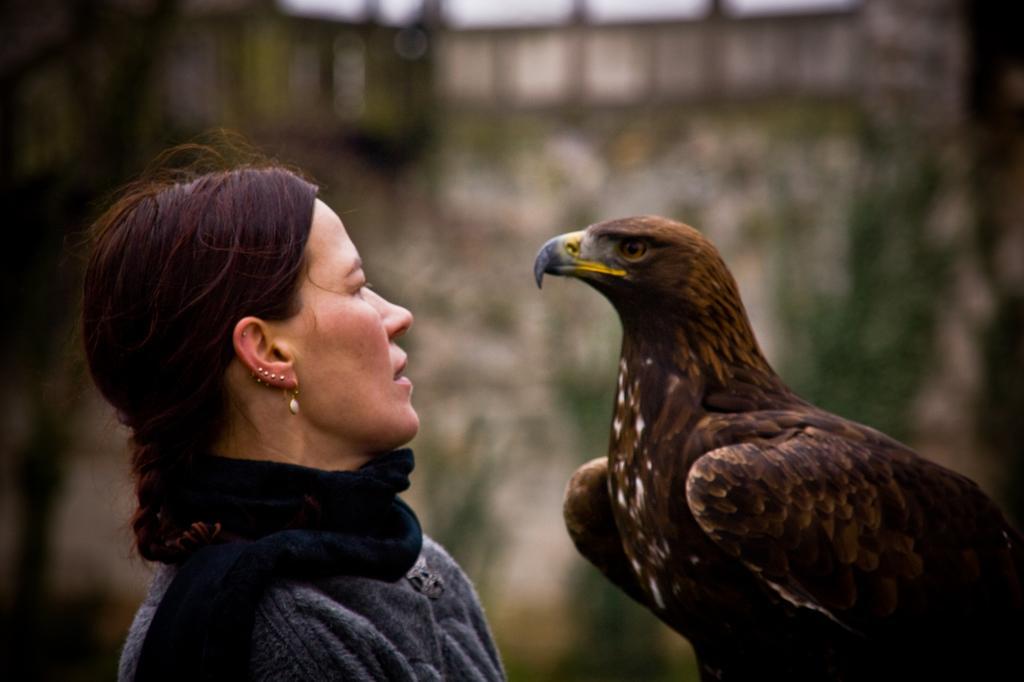Could you give a brief overview of what you see in this image? In this image we can see a person and an eagle. In the background of the image there is a blur background. 